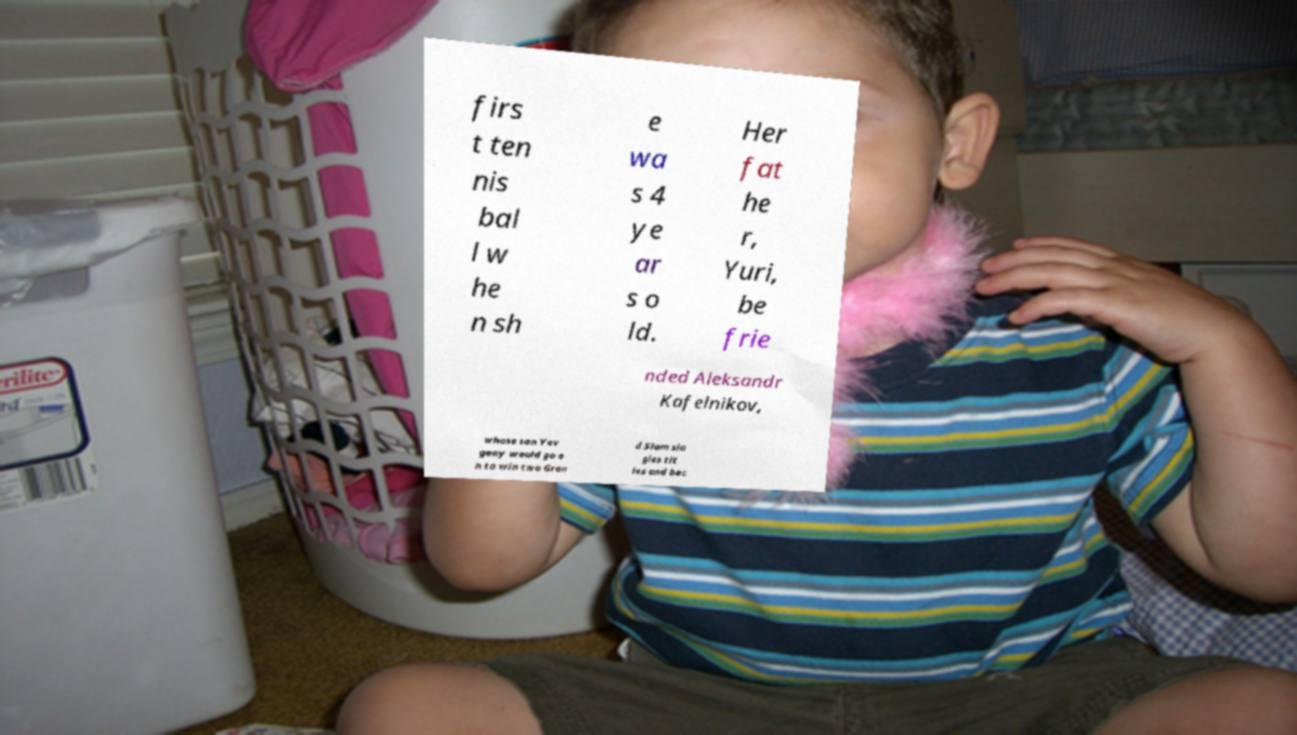I need the written content from this picture converted into text. Can you do that? firs t ten nis bal l w he n sh e wa s 4 ye ar s o ld. Her fat he r, Yuri, be frie nded Aleksandr Kafelnikov, whose son Yev geny would go o n to win two Gran d Slam sin gles tit les and bec 